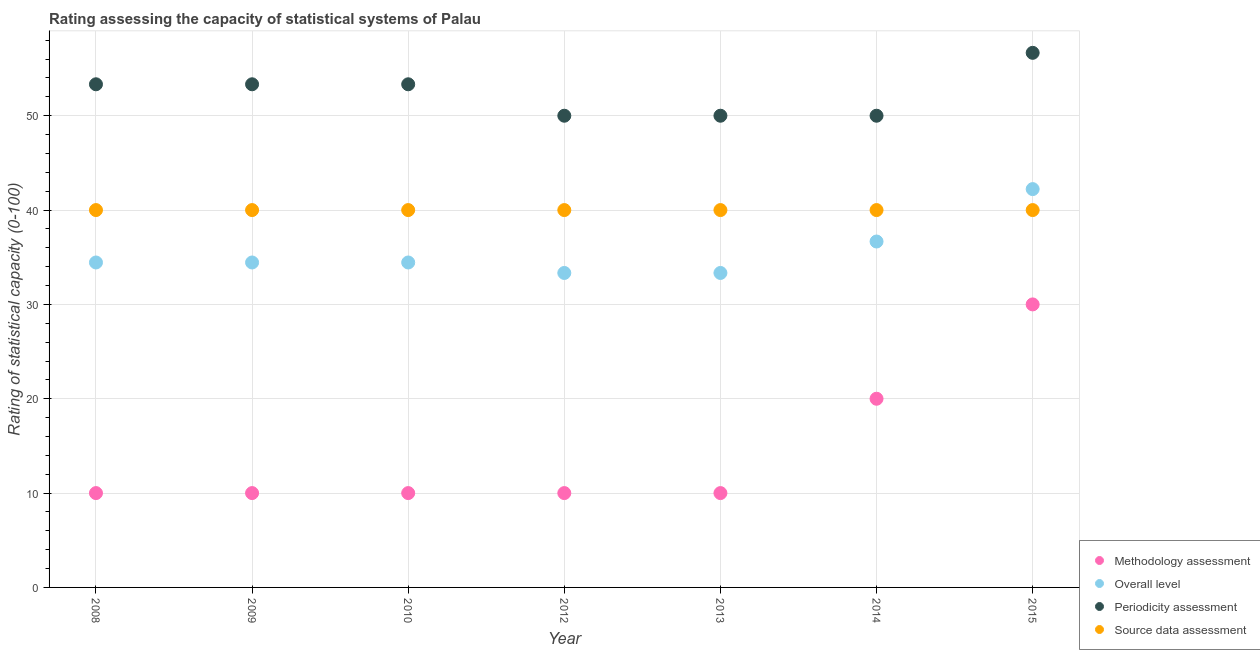What is the methodology assessment rating in 2015?
Offer a terse response. 30. Across all years, what is the maximum periodicity assessment rating?
Provide a succinct answer. 56.67. Across all years, what is the minimum source data assessment rating?
Your response must be concise. 40. In which year was the periodicity assessment rating maximum?
Ensure brevity in your answer.  2015. What is the total periodicity assessment rating in the graph?
Ensure brevity in your answer.  366.67. What is the difference between the overall level rating in 2008 and that in 2010?
Offer a very short reply. 0. What is the difference between the source data assessment rating in 2008 and the overall level rating in 2015?
Offer a terse response. -2.22. What is the average overall level rating per year?
Provide a succinct answer. 35.56. In the year 2012, what is the difference between the overall level rating and periodicity assessment rating?
Offer a terse response. -16.67. In how many years, is the methodology assessment rating greater than 36?
Give a very brief answer. 0. What is the ratio of the methodology assessment rating in 2010 to that in 2013?
Your response must be concise. 1. Is the difference between the source data assessment rating in 2008 and 2015 greater than the difference between the overall level rating in 2008 and 2015?
Your answer should be compact. Yes. What is the difference between the highest and the second highest methodology assessment rating?
Your response must be concise. 10. What is the difference between the highest and the lowest methodology assessment rating?
Your response must be concise. 20. In how many years, is the overall level rating greater than the average overall level rating taken over all years?
Make the answer very short. 2. Is it the case that in every year, the sum of the periodicity assessment rating and source data assessment rating is greater than the sum of overall level rating and methodology assessment rating?
Your answer should be compact. Yes. Is it the case that in every year, the sum of the methodology assessment rating and overall level rating is greater than the periodicity assessment rating?
Offer a terse response. No. Is the methodology assessment rating strictly greater than the source data assessment rating over the years?
Ensure brevity in your answer.  No. What is the difference between two consecutive major ticks on the Y-axis?
Your answer should be very brief. 10. Are the values on the major ticks of Y-axis written in scientific E-notation?
Provide a short and direct response. No. Does the graph contain any zero values?
Give a very brief answer. No. Does the graph contain grids?
Offer a terse response. Yes. What is the title of the graph?
Your answer should be compact. Rating assessing the capacity of statistical systems of Palau. What is the label or title of the X-axis?
Give a very brief answer. Year. What is the label or title of the Y-axis?
Your response must be concise. Rating of statistical capacity (0-100). What is the Rating of statistical capacity (0-100) of Methodology assessment in 2008?
Your response must be concise. 10. What is the Rating of statistical capacity (0-100) of Overall level in 2008?
Keep it short and to the point. 34.44. What is the Rating of statistical capacity (0-100) in Periodicity assessment in 2008?
Offer a very short reply. 53.33. What is the Rating of statistical capacity (0-100) in Overall level in 2009?
Your response must be concise. 34.44. What is the Rating of statistical capacity (0-100) of Periodicity assessment in 2009?
Provide a short and direct response. 53.33. What is the Rating of statistical capacity (0-100) in Source data assessment in 2009?
Offer a terse response. 40. What is the Rating of statistical capacity (0-100) in Overall level in 2010?
Offer a terse response. 34.44. What is the Rating of statistical capacity (0-100) of Periodicity assessment in 2010?
Provide a short and direct response. 53.33. What is the Rating of statistical capacity (0-100) of Methodology assessment in 2012?
Your answer should be very brief. 10. What is the Rating of statistical capacity (0-100) of Overall level in 2012?
Give a very brief answer. 33.33. What is the Rating of statistical capacity (0-100) in Source data assessment in 2012?
Provide a short and direct response. 40. What is the Rating of statistical capacity (0-100) of Overall level in 2013?
Provide a succinct answer. 33.33. What is the Rating of statistical capacity (0-100) of Periodicity assessment in 2013?
Provide a succinct answer. 50. What is the Rating of statistical capacity (0-100) in Source data assessment in 2013?
Offer a terse response. 40. What is the Rating of statistical capacity (0-100) of Methodology assessment in 2014?
Provide a succinct answer. 20. What is the Rating of statistical capacity (0-100) of Overall level in 2014?
Offer a terse response. 36.67. What is the Rating of statistical capacity (0-100) of Periodicity assessment in 2014?
Offer a terse response. 50. What is the Rating of statistical capacity (0-100) of Overall level in 2015?
Ensure brevity in your answer.  42.22. What is the Rating of statistical capacity (0-100) of Periodicity assessment in 2015?
Keep it short and to the point. 56.67. Across all years, what is the maximum Rating of statistical capacity (0-100) of Overall level?
Your answer should be very brief. 42.22. Across all years, what is the maximum Rating of statistical capacity (0-100) in Periodicity assessment?
Your response must be concise. 56.67. Across all years, what is the maximum Rating of statistical capacity (0-100) of Source data assessment?
Provide a short and direct response. 40. Across all years, what is the minimum Rating of statistical capacity (0-100) in Methodology assessment?
Make the answer very short. 10. Across all years, what is the minimum Rating of statistical capacity (0-100) of Overall level?
Give a very brief answer. 33.33. What is the total Rating of statistical capacity (0-100) of Methodology assessment in the graph?
Make the answer very short. 100. What is the total Rating of statistical capacity (0-100) of Overall level in the graph?
Make the answer very short. 248.89. What is the total Rating of statistical capacity (0-100) in Periodicity assessment in the graph?
Provide a succinct answer. 366.67. What is the total Rating of statistical capacity (0-100) of Source data assessment in the graph?
Give a very brief answer. 280. What is the difference between the Rating of statistical capacity (0-100) in Methodology assessment in 2008 and that in 2009?
Offer a very short reply. 0. What is the difference between the Rating of statistical capacity (0-100) of Overall level in 2008 and that in 2009?
Your answer should be compact. 0. What is the difference between the Rating of statistical capacity (0-100) of Periodicity assessment in 2008 and that in 2009?
Make the answer very short. 0. What is the difference between the Rating of statistical capacity (0-100) of Source data assessment in 2008 and that in 2010?
Your answer should be very brief. 0. What is the difference between the Rating of statistical capacity (0-100) of Overall level in 2008 and that in 2013?
Offer a terse response. 1.11. What is the difference between the Rating of statistical capacity (0-100) in Periodicity assessment in 2008 and that in 2013?
Offer a very short reply. 3.33. What is the difference between the Rating of statistical capacity (0-100) in Source data assessment in 2008 and that in 2013?
Offer a very short reply. 0. What is the difference between the Rating of statistical capacity (0-100) in Overall level in 2008 and that in 2014?
Offer a very short reply. -2.22. What is the difference between the Rating of statistical capacity (0-100) in Periodicity assessment in 2008 and that in 2014?
Give a very brief answer. 3.33. What is the difference between the Rating of statistical capacity (0-100) of Source data assessment in 2008 and that in 2014?
Your answer should be very brief. 0. What is the difference between the Rating of statistical capacity (0-100) of Methodology assessment in 2008 and that in 2015?
Provide a succinct answer. -20. What is the difference between the Rating of statistical capacity (0-100) in Overall level in 2008 and that in 2015?
Offer a very short reply. -7.78. What is the difference between the Rating of statistical capacity (0-100) in Source data assessment in 2008 and that in 2015?
Your answer should be compact. 0. What is the difference between the Rating of statistical capacity (0-100) in Overall level in 2009 and that in 2010?
Keep it short and to the point. 0. What is the difference between the Rating of statistical capacity (0-100) in Periodicity assessment in 2009 and that in 2010?
Offer a very short reply. 0. What is the difference between the Rating of statistical capacity (0-100) of Methodology assessment in 2009 and that in 2012?
Offer a very short reply. 0. What is the difference between the Rating of statistical capacity (0-100) of Periodicity assessment in 2009 and that in 2012?
Your response must be concise. 3.33. What is the difference between the Rating of statistical capacity (0-100) of Source data assessment in 2009 and that in 2012?
Offer a terse response. 0. What is the difference between the Rating of statistical capacity (0-100) of Methodology assessment in 2009 and that in 2013?
Your answer should be very brief. 0. What is the difference between the Rating of statistical capacity (0-100) in Periodicity assessment in 2009 and that in 2013?
Your answer should be very brief. 3.33. What is the difference between the Rating of statistical capacity (0-100) in Source data assessment in 2009 and that in 2013?
Offer a very short reply. 0. What is the difference between the Rating of statistical capacity (0-100) of Overall level in 2009 and that in 2014?
Ensure brevity in your answer.  -2.22. What is the difference between the Rating of statistical capacity (0-100) of Periodicity assessment in 2009 and that in 2014?
Ensure brevity in your answer.  3.33. What is the difference between the Rating of statistical capacity (0-100) of Source data assessment in 2009 and that in 2014?
Your answer should be compact. 0. What is the difference between the Rating of statistical capacity (0-100) in Overall level in 2009 and that in 2015?
Keep it short and to the point. -7.78. What is the difference between the Rating of statistical capacity (0-100) of Source data assessment in 2009 and that in 2015?
Provide a short and direct response. 0. What is the difference between the Rating of statistical capacity (0-100) in Methodology assessment in 2010 and that in 2012?
Your response must be concise. 0. What is the difference between the Rating of statistical capacity (0-100) in Periodicity assessment in 2010 and that in 2012?
Your answer should be compact. 3.33. What is the difference between the Rating of statistical capacity (0-100) of Source data assessment in 2010 and that in 2012?
Give a very brief answer. 0. What is the difference between the Rating of statistical capacity (0-100) of Periodicity assessment in 2010 and that in 2013?
Your answer should be very brief. 3.33. What is the difference between the Rating of statistical capacity (0-100) in Source data assessment in 2010 and that in 2013?
Your response must be concise. 0. What is the difference between the Rating of statistical capacity (0-100) in Methodology assessment in 2010 and that in 2014?
Ensure brevity in your answer.  -10. What is the difference between the Rating of statistical capacity (0-100) of Overall level in 2010 and that in 2014?
Your response must be concise. -2.22. What is the difference between the Rating of statistical capacity (0-100) of Methodology assessment in 2010 and that in 2015?
Offer a terse response. -20. What is the difference between the Rating of statistical capacity (0-100) in Overall level in 2010 and that in 2015?
Ensure brevity in your answer.  -7.78. What is the difference between the Rating of statistical capacity (0-100) of Source data assessment in 2010 and that in 2015?
Keep it short and to the point. 0. What is the difference between the Rating of statistical capacity (0-100) in Periodicity assessment in 2012 and that in 2013?
Offer a very short reply. 0. What is the difference between the Rating of statistical capacity (0-100) of Methodology assessment in 2012 and that in 2014?
Provide a short and direct response. -10. What is the difference between the Rating of statistical capacity (0-100) in Periodicity assessment in 2012 and that in 2014?
Offer a very short reply. 0. What is the difference between the Rating of statistical capacity (0-100) of Overall level in 2012 and that in 2015?
Your answer should be compact. -8.89. What is the difference between the Rating of statistical capacity (0-100) in Periodicity assessment in 2012 and that in 2015?
Your response must be concise. -6.67. What is the difference between the Rating of statistical capacity (0-100) of Source data assessment in 2012 and that in 2015?
Give a very brief answer. 0. What is the difference between the Rating of statistical capacity (0-100) of Methodology assessment in 2013 and that in 2014?
Your response must be concise. -10. What is the difference between the Rating of statistical capacity (0-100) in Overall level in 2013 and that in 2014?
Keep it short and to the point. -3.33. What is the difference between the Rating of statistical capacity (0-100) in Source data assessment in 2013 and that in 2014?
Offer a terse response. 0. What is the difference between the Rating of statistical capacity (0-100) of Methodology assessment in 2013 and that in 2015?
Ensure brevity in your answer.  -20. What is the difference between the Rating of statistical capacity (0-100) in Overall level in 2013 and that in 2015?
Provide a succinct answer. -8.89. What is the difference between the Rating of statistical capacity (0-100) of Periodicity assessment in 2013 and that in 2015?
Provide a short and direct response. -6.67. What is the difference between the Rating of statistical capacity (0-100) in Overall level in 2014 and that in 2015?
Provide a succinct answer. -5.56. What is the difference between the Rating of statistical capacity (0-100) of Periodicity assessment in 2014 and that in 2015?
Your answer should be compact. -6.67. What is the difference between the Rating of statistical capacity (0-100) in Methodology assessment in 2008 and the Rating of statistical capacity (0-100) in Overall level in 2009?
Make the answer very short. -24.44. What is the difference between the Rating of statistical capacity (0-100) of Methodology assessment in 2008 and the Rating of statistical capacity (0-100) of Periodicity assessment in 2009?
Make the answer very short. -43.33. What is the difference between the Rating of statistical capacity (0-100) in Overall level in 2008 and the Rating of statistical capacity (0-100) in Periodicity assessment in 2009?
Keep it short and to the point. -18.89. What is the difference between the Rating of statistical capacity (0-100) of Overall level in 2008 and the Rating of statistical capacity (0-100) of Source data assessment in 2009?
Provide a succinct answer. -5.56. What is the difference between the Rating of statistical capacity (0-100) of Periodicity assessment in 2008 and the Rating of statistical capacity (0-100) of Source data assessment in 2009?
Give a very brief answer. 13.33. What is the difference between the Rating of statistical capacity (0-100) of Methodology assessment in 2008 and the Rating of statistical capacity (0-100) of Overall level in 2010?
Make the answer very short. -24.44. What is the difference between the Rating of statistical capacity (0-100) in Methodology assessment in 2008 and the Rating of statistical capacity (0-100) in Periodicity assessment in 2010?
Make the answer very short. -43.33. What is the difference between the Rating of statistical capacity (0-100) of Methodology assessment in 2008 and the Rating of statistical capacity (0-100) of Source data assessment in 2010?
Offer a very short reply. -30. What is the difference between the Rating of statistical capacity (0-100) of Overall level in 2008 and the Rating of statistical capacity (0-100) of Periodicity assessment in 2010?
Make the answer very short. -18.89. What is the difference between the Rating of statistical capacity (0-100) in Overall level in 2008 and the Rating of statistical capacity (0-100) in Source data assessment in 2010?
Keep it short and to the point. -5.56. What is the difference between the Rating of statistical capacity (0-100) of Periodicity assessment in 2008 and the Rating of statistical capacity (0-100) of Source data assessment in 2010?
Keep it short and to the point. 13.33. What is the difference between the Rating of statistical capacity (0-100) of Methodology assessment in 2008 and the Rating of statistical capacity (0-100) of Overall level in 2012?
Provide a succinct answer. -23.33. What is the difference between the Rating of statistical capacity (0-100) in Overall level in 2008 and the Rating of statistical capacity (0-100) in Periodicity assessment in 2012?
Your answer should be compact. -15.56. What is the difference between the Rating of statistical capacity (0-100) in Overall level in 2008 and the Rating of statistical capacity (0-100) in Source data assessment in 2012?
Make the answer very short. -5.56. What is the difference between the Rating of statistical capacity (0-100) in Periodicity assessment in 2008 and the Rating of statistical capacity (0-100) in Source data assessment in 2012?
Give a very brief answer. 13.33. What is the difference between the Rating of statistical capacity (0-100) of Methodology assessment in 2008 and the Rating of statistical capacity (0-100) of Overall level in 2013?
Your response must be concise. -23.33. What is the difference between the Rating of statistical capacity (0-100) in Methodology assessment in 2008 and the Rating of statistical capacity (0-100) in Periodicity assessment in 2013?
Make the answer very short. -40. What is the difference between the Rating of statistical capacity (0-100) of Overall level in 2008 and the Rating of statistical capacity (0-100) of Periodicity assessment in 2013?
Provide a succinct answer. -15.56. What is the difference between the Rating of statistical capacity (0-100) of Overall level in 2008 and the Rating of statistical capacity (0-100) of Source data assessment in 2013?
Make the answer very short. -5.56. What is the difference between the Rating of statistical capacity (0-100) in Periodicity assessment in 2008 and the Rating of statistical capacity (0-100) in Source data assessment in 2013?
Keep it short and to the point. 13.33. What is the difference between the Rating of statistical capacity (0-100) of Methodology assessment in 2008 and the Rating of statistical capacity (0-100) of Overall level in 2014?
Ensure brevity in your answer.  -26.67. What is the difference between the Rating of statistical capacity (0-100) in Methodology assessment in 2008 and the Rating of statistical capacity (0-100) in Periodicity assessment in 2014?
Keep it short and to the point. -40. What is the difference between the Rating of statistical capacity (0-100) of Methodology assessment in 2008 and the Rating of statistical capacity (0-100) of Source data assessment in 2014?
Your answer should be compact. -30. What is the difference between the Rating of statistical capacity (0-100) in Overall level in 2008 and the Rating of statistical capacity (0-100) in Periodicity assessment in 2014?
Provide a succinct answer. -15.56. What is the difference between the Rating of statistical capacity (0-100) in Overall level in 2008 and the Rating of statistical capacity (0-100) in Source data assessment in 2014?
Make the answer very short. -5.56. What is the difference between the Rating of statistical capacity (0-100) of Periodicity assessment in 2008 and the Rating of statistical capacity (0-100) of Source data assessment in 2014?
Ensure brevity in your answer.  13.33. What is the difference between the Rating of statistical capacity (0-100) in Methodology assessment in 2008 and the Rating of statistical capacity (0-100) in Overall level in 2015?
Your answer should be compact. -32.22. What is the difference between the Rating of statistical capacity (0-100) in Methodology assessment in 2008 and the Rating of statistical capacity (0-100) in Periodicity assessment in 2015?
Offer a terse response. -46.67. What is the difference between the Rating of statistical capacity (0-100) of Overall level in 2008 and the Rating of statistical capacity (0-100) of Periodicity assessment in 2015?
Keep it short and to the point. -22.22. What is the difference between the Rating of statistical capacity (0-100) in Overall level in 2008 and the Rating of statistical capacity (0-100) in Source data assessment in 2015?
Provide a short and direct response. -5.56. What is the difference between the Rating of statistical capacity (0-100) in Periodicity assessment in 2008 and the Rating of statistical capacity (0-100) in Source data assessment in 2015?
Make the answer very short. 13.33. What is the difference between the Rating of statistical capacity (0-100) in Methodology assessment in 2009 and the Rating of statistical capacity (0-100) in Overall level in 2010?
Make the answer very short. -24.44. What is the difference between the Rating of statistical capacity (0-100) in Methodology assessment in 2009 and the Rating of statistical capacity (0-100) in Periodicity assessment in 2010?
Make the answer very short. -43.33. What is the difference between the Rating of statistical capacity (0-100) of Overall level in 2009 and the Rating of statistical capacity (0-100) of Periodicity assessment in 2010?
Provide a short and direct response. -18.89. What is the difference between the Rating of statistical capacity (0-100) of Overall level in 2009 and the Rating of statistical capacity (0-100) of Source data assessment in 2010?
Your response must be concise. -5.56. What is the difference between the Rating of statistical capacity (0-100) in Periodicity assessment in 2009 and the Rating of statistical capacity (0-100) in Source data assessment in 2010?
Offer a very short reply. 13.33. What is the difference between the Rating of statistical capacity (0-100) of Methodology assessment in 2009 and the Rating of statistical capacity (0-100) of Overall level in 2012?
Your answer should be compact. -23.33. What is the difference between the Rating of statistical capacity (0-100) in Overall level in 2009 and the Rating of statistical capacity (0-100) in Periodicity assessment in 2012?
Make the answer very short. -15.56. What is the difference between the Rating of statistical capacity (0-100) of Overall level in 2009 and the Rating of statistical capacity (0-100) of Source data assessment in 2012?
Your response must be concise. -5.56. What is the difference between the Rating of statistical capacity (0-100) in Periodicity assessment in 2009 and the Rating of statistical capacity (0-100) in Source data assessment in 2012?
Your answer should be very brief. 13.33. What is the difference between the Rating of statistical capacity (0-100) in Methodology assessment in 2009 and the Rating of statistical capacity (0-100) in Overall level in 2013?
Provide a succinct answer. -23.33. What is the difference between the Rating of statistical capacity (0-100) of Overall level in 2009 and the Rating of statistical capacity (0-100) of Periodicity assessment in 2013?
Provide a succinct answer. -15.56. What is the difference between the Rating of statistical capacity (0-100) of Overall level in 2009 and the Rating of statistical capacity (0-100) of Source data assessment in 2013?
Make the answer very short. -5.56. What is the difference between the Rating of statistical capacity (0-100) in Periodicity assessment in 2009 and the Rating of statistical capacity (0-100) in Source data assessment in 2013?
Your answer should be compact. 13.33. What is the difference between the Rating of statistical capacity (0-100) of Methodology assessment in 2009 and the Rating of statistical capacity (0-100) of Overall level in 2014?
Give a very brief answer. -26.67. What is the difference between the Rating of statistical capacity (0-100) of Methodology assessment in 2009 and the Rating of statistical capacity (0-100) of Periodicity assessment in 2014?
Offer a terse response. -40. What is the difference between the Rating of statistical capacity (0-100) of Overall level in 2009 and the Rating of statistical capacity (0-100) of Periodicity assessment in 2014?
Give a very brief answer. -15.56. What is the difference between the Rating of statistical capacity (0-100) in Overall level in 2009 and the Rating of statistical capacity (0-100) in Source data assessment in 2014?
Make the answer very short. -5.56. What is the difference between the Rating of statistical capacity (0-100) of Periodicity assessment in 2009 and the Rating of statistical capacity (0-100) of Source data assessment in 2014?
Ensure brevity in your answer.  13.33. What is the difference between the Rating of statistical capacity (0-100) of Methodology assessment in 2009 and the Rating of statistical capacity (0-100) of Overall level in 2015?
Provide a succinct answer. -32.22. What is the difference between the Rating of statistical capacity (0-100) in Methodology assessment in 2009 and the Rating of statistical capacity (0-100) in Periodicity assessment in 2015?
Ensure brevity in your answer.  -46.67. What is the difference between the Rating of statistical capacity (0-100) of Overall level in 2009 and the Rating of statistical capacity (0-100) of Periodicity assessment in 2015?
Offer a very short reply. -22.22. What is the difference between the Rating of statistical capacity (0-100) of Overall level in 2009 and the Rating of statistical capacity (0-100) of Source data assessment in 2015?
Give a very brief answer. -5.56. What is the difference between the Rating of statistical capacity (0-100) in Periodicity assessment in 2009 and the Rating of statistical capacity (0-100) in Source data assessment in 2015?
Your response must be concise. 13.33. What is the difference between the Rating of statistical capacity (0-100) of Methodology assessment in 2010 and the Rating of statistical capacity (0-100) of Overall level in 2012?
Keep it short and to the point. -23.33. What is the difference between the Rating of statistical capacity (0-100) of Overall level in 2010 and the Rating of statistical capacity (0-100) of Periodicity assessment in 2012?
Keep it short and to the point. -15.56. What is the difference between the Rating of statistical capacity (0-100) in Overall level in 2010 and the Rating of statistical capacity (0-100) in Source data assessment in 2012?
Provide a short and direct response. -5.56. What is the difference between the Rating of statistical capacity (0-100) in Periodicity assessment in 2010 and the Rating of statistical capacity (0-100) in Source data assessment in 2012?
Your response must be concise. 13.33. What is the difference between the Rating of statistical capacity (0-100) of Methodology assessment in 2010 and the Rating of statistical capacity (0-100) of Overall level in 2013?
Ensure brevity in your answer.  -23.33. What is the difference between the Rating of statistical capacity (0-100) of Overall level in 2010 and the Rating of statistical capacity (0-100) of Periodicity assessment in 2013?
Give a very brief answer. -15.56. What is the difference between the Rating of statistical capacity (0-100) of Overall level in 2010 and the Rating of statistical capacity (0-100) of Source data assessment in 2013?
Offer a terse response. -5.56. What is the difference between the Rating of statistical capacity (0-100) of Periodicity assessment in 2010 and the Rating of statistical capacity (0-100) of Source data assessment in 2013?
Your answer should be compact. 13.33. What is the difference between the Rating of statistical capacity (0-100) of Methodology assessment in 2010 and the Rating of statistical capacity (0-100) of Overall level in 2014?
Ensure brevity in your answer.  -26.67. What is the difference between the Rating of statistical capacity (0-100) in Methodology assessment in 2010 and the Rating of statistical capacity (0-100) in Periodicity assessment in 2014?
Offer a very short reply. -40. What is the difference between the Rating of statistical capacity (0-100) in Methodology assessment in 2010 and the Rating of statistical capacity (0-100) in Source data assessment in 2014?
Your answer should be compact. -30. What is the difference between the Rating of statistical capacity (0-100) of Overall level in 2010 and the Rating of statistical capacity (0-100) of Periodicity assessment in 2014?
Ensure brevity in your answer.  -15.56. What is the difference between the Rating of statistical capacity (0-100) of Overall level in 2010 and the Rating of statistical capacity (0-100) of Source data assessment in 2014?
Keep it short and to the point. -5.56. What is the difference between the Rating of statistical capacity (0-100) in Periodicity assessment in 2010 and the Rating of statistical capacity (0-100) in Source data assessment in 2014?
Make the answer very short. 13.33. What is the difference between the Rating of statistical capacity (0-100) in Methodology assessment in 2010 and the Rating of statistical capacity (0-100) in Overall level in 2015?
Your response must be concise. -32.22. What is the difference between the Rating of statistical capacity (0-100) in Methodology assessment in 2010 and the Rating of statistical capacity (0-100) in Periodicity assessment in 2015?
Give a very brief answer. -46.67. What is the difference between the Rating of statistical capacity (0-100) in Methodology assessment in 2010 and the Rating of statistical capacity (0-100) in Source data assessment in 2015?
Provide a succinct answer. -30. What is the difference between the Rating of statistical capacity (0-100) in Overall level in 2010 and the Rating of statistical capacity (0-100) in Periodicity assessment in 2015?
Offer a very short reply. -22.22. What is the difference between the Rating of statistical capacity (0-100) in Overall level in 2010 and the Rating of statistical capacity (0-100) in Source data assessment in 2015?
Provide a short and direct response. -5.56. What is the difference between the Rating of statistical capacity (0-100) in Periodicity assessment in 2010 and the Rating of statistical capacity (0-100) in Source data assessment in 2015?
Give a very brief answer. 13.33. What is the difference between the Rating of statistical capacity (0-100) in Methodology assessment in 2012 and the Rating of statistical capacity (0-100) in Overall level in 2013?
Your response must be concise. -23.33. What is the difference between the Rating of statistical capacity (0-100) of Overall level in 2012 and the Rating of statistical capacity (0-100) of Periodicity assessment in 2013?
Ensure brevity in your answer.  -16.67. What is the difference between the Rating of statistical capacity (0-100) of Overall level in 2012 and the Rating of statistical capacity (0-100) of Source data assessment in 2013?
Offer a very short reply. -6.67. What is the difference between the Rating of statistical capacity (0-100) of Methodology assessment in 2012 and the Rating of statistical capacity (0-100) of Overall level in 2014?
Your response must be concise. -26.67. What is the difference between the Rating of statistical capacity (0-100) of Methodology assessment in 2012 and the Rating of statistical capacity (0-100) of Periodicity assessment in 2014?
Your answer should be compact. -40. What is the difference between the Rating of statistical capacity (0-100) in Overall level in 2012 and the Rating of statistical capacity (0-100) in Periodicity assessment in 2014?
Provide a short and direct response. -16.67. What is the difference between the Rating of statistical capacity (0-100) of Overall level in 2012 and the Rating of statistical capacity (0-100) of Source data assessment in 2014?
Make the answer very short. -6.67. What is the difference between the Rating of statistical capacity (0-100) of Methodology assessment in 2012 and the Rating of statistical capacity (0-100) of Overall level in 2015?
Offer a very short reply. -32.22. What is the difference between the Rating of statistical capacity (0-100) in Methodology assessment in 2012 and the Rating of statistical capacity (0-100) in Periodicity assessment in 2015?
Your response must be concise. -46.67. What is the difference between the Rating of statistical capacity (0-100) of Methodology assessment in 2012 and the Rating of statistical capacity (0-100) of Source data assessment in 2015?
Offer a terse response. -30. What is the difference between the Rating of statistical capacity (0-100) of Overall level in 2012 and the Rating of statistical capacity (0-100) of Periodicity assessment in 2015?
Your answer should be compact. -23.33. What is the difference between the Rating of statistical capacity (0-100) of Overall level in 2012 and the Rating of statistical capacity (0-100) of Source data assessment in 2015?
Make the answer very short. -6.67. What is the difference between the Rating of statistical capacity (0-100) in Periodicity assessment in 2012 and the Rating of statistical capacity (0-100) in Source data assessment in 2015?
Your answer should be very brief. 10. What is the difference between the Rating of statistical capacity (0-100) in Methodology assessment in 2013 and the Rating of statistical capacity (0-100) in Overall level in 2014?
Provide a short and direct response. -26.67. What is the difference between the Rating of statistical capacity (0-100) of Overall level in 2013 and the Rating of statistical capacity (0-100) of Periodicity assessment in 2014?
Your response must be concise. -16.67. What is the difference between the Rating of statistical capacity (0-100) of Overall level in 2013 and the Rating of statistical capacity (0-100) of Source data assessment in 2014?
Offer a terse response. -6.67. What is the difference between the Rating of statistical capacity (0-100) of Methodology assessment in 2013 and the Rating of statistical capacity (0-100) of Overall level in 2015?
Your answer should be very brief. -32.22. What is the difference between the Rating of statistical capacity (0-100) of Methodology assessment in 2013 and the Rating of statistical capacity (0-100) of Periodicity assessment in 2015?
Offer a very short reply. -46.67. What is the difference between the Rating of statistical capacity (0-100) of Methodology assessment in 2013 and the Rating of statistical capacity (0-100) of Source data assessment in 2015?
Your response must be concise. -30. What is the difference between the Rating of statistical capacity (0-100) of Overall level in 2013 and the Rating of statistical capacity (0-100) of Periodicity assessment in 2015?
Give a very brief answer. -23.33. What is the difference between the Rating of statistical capacity (0-100) of Overall level in 2013 and the Rating of statistical capacity (0-100) of Source data assessment in 2015?
Offer a terse response. -6.67. What is the difference between the Rating of statistical capacity (0-100) of Periodicity assessment in 2013 and the Rating of statistical capacity (0-100) of Source data assessment in 2015?
Give a very brief answer. 10. What is the difference between the Rating of statistical capacity (0-100) in Methodology assessment in 2014 and the Rating of statistical capacity (0-100) in Overall level in 2015?
Keep it short and to the point. -22.22. What is the difference between the Rating of statistical capacity (0-100) of Methodology assessment in 2014 and the Rating of statistical capacity (0-100) of Periodicity assessment in 2015?
Make the answer very short. -36.67. What is the difference between the Rating of statistical capacity (0-100) of Methodology assessment in 2014 and the Rating of statistical capacity (0-100) of Source data assessment in 2015?
Give a very brief answer. -20. What is the difference between the Rating of statistical capacity (0-100) of Overall level in 2014 and the Rating of statistical capacity (0-100) of Periodicity assessment in 2015?
Give a very brief answer. -20. What is the average Rating of statistical capacity (0-100) in Methodology assessment per year?
Your answer should be compact. 14.29. What is the average Rating of statistical capacity (0-100) of Overall level per year?
Make the answer very short. 35.56. What is the average Rating of statistical capacity (0-100) of Periodicity assessment per year?
Your response must be concise. 52.38. In the year 2008, what is the difference between the Rating of statistical capacity (0-100) in Methodology assessment and Rating of statistical capacity (0-100) in Overall level?
Give a very brief answer. -24.44. In the year 2008, what is the difference between the Rating of statistical capacity (0-100) in Methodology assessment and Rating of statistical capacity (0-100) in Periodicity assessment?
Provide a succinct answer. -43.33. In the year 2008, what is the difference between the Rating of statistical capacity (0-100) in Overall level and Rating of statistical capacity (0-100) in Periodicity assessment?
Offer a very short reply. -18.89. In the year 2008, what is the difference between the Rating of statistical capacity (0-100) in Overall level and Rating of statistical capacity (0-100) in Source data assessment?
Give a very brief answer. -5.56. In the year 2008, what is the difference between the Rating of statistical capacity (0-100) in Periodicity assessment and Rating of statistical capacity (0-100) in Source data assessment?
Keep it short and to the point. 13.33. In the year 2009, what is the difference between the Rating of statistical capacity (0-100) of Methodology assessment and Rating of statistical capacity (0-100) of Overall level?
Make the answer very short. -24.44. In the year 2009, what is the difference between the Rating of statistical capacity (0-100) in Methodology assessment and Rating of statistical capacity (0-100) in Periodicity assessment?
Your answer should be compact. -43.33. In the year 2009, what is the difference between the Rating of statistical capacity (0-100) in Overall level and Rating of statistical capacity (0-100) in Periodicity assessment?
Your response must be concise. -18.89. In the year 2009, what is the difference between the Rating of statistical capacity (0-100) in Overall level and Rating of statistical capacity (0-100) in Source data assessment?
Offer a very short reply. -5.56. In the year 2009, what is the difference between the Rating of statistical capacity (0-100) of Periodicity assessment and Rating of statistical capacity (0-100) of Source data assessment?
Your answer should be compact. 13.33. In the year 2010, what is the difference between the Rating of statistical capacity (0-100) in Methodology assessment and Rating of statistical capacity (0-100) in Overall level?
Your answer should be very brief. -24.44. In the year 2010, what is the difference between the Rating of statistical capacity (0-100) in Methodology assessment and Rating of statistical capacity (0-100) in Periodicity assessment?
Make the answer very short. -43.33. In the year 2010, what is the difference between the Rating of statistical capacity (0-100) in Overall level and Rating of statistical capacity (0-100) in Periodicity assessment?
Offer a very short reply. -18.89. In the year 2010, what is the difference between the Rating of statistical capacity (0-100) in Overall level and Rating of statistical capacity (0-100) in Source data assessment?
Your response must be concise. -5.56. In the year 2010, what is the difference between the Rating of statistical capacity (0-100) in Periodicity assessment and Rating of statistical capacity (0-100) in Source data assessment?
Offer a very short reply. 13.33. In the year 2012, what is the difference between the Rating of statistical capacity (0-100) in Methodology assessment and Rating of statistical capacity (0-100) in Overall level?
Your answer should be compact. -23.33. In the year 2012, what is the difference between the Rating of statistical capacity (0-100) of Methodology assessment and Rating of statistical capacity (0-100) of Periodicity assessment?
Provide a short and direct response. -40. In the year 2012, what is the difference between the Rating of statistical capacity (0-100) in Overall level and Rating of statistical capacity (0-100) in Periodicity assessment?
Ensure brevity in your answer.  -16.67. In the year 2012, what is the difference between the Rating of statistical capacity (0-100) of Overall level and Rating of statistical capacity (0-100) of Source data assessment?
Keep it short and to the point. -6.67. In the year 2012, what is the difference between the Rating of statistical capacity (0-100) in Periodicity assessment and Rating of statistical capacity (0-100) in Source data assessment?
Your answer should be compact. 10. In the year 2013, what is the difference between the Rating of statistical capacity (0-100) of Methodology assessment and Rating of statistical capacity (0-100) of Overall level?
Offer a terse response. -23.33. In the year 2013, what is the difference between the Rating of statistical capacity (0-100) of Methodology assessment and Rating of statistical capacity (0-100) of Periodicity assessment?
Give a very brief answer. -40. In the year 2013, what is the difference between the Rating of statistical capacity (0-100) in Methodology assessment and Rating of statistical capacity (0-100) in Source data assessment?
Give a very brief answer. -30. In the year 2013, what is the difference between the Rating of statistical capacity (0-100) in Overall level and Rating of statistical capacity (0-100) in Periodicity assessment?
Your answer should be very brief. -16.67. In the year 2013, what is the difference between the Rating of statistical capacity (0-100) in Overall level and Rating of statistical capacity (0-100) in Source data assessment?
Provide a succinct answer. -6.67. In the year 2014, what is the difference between the Rating of statistical capacity (0-100) in Methodology assessment and Rating of statistical capacity (0-100) in Overall level?
Your answer should be compact. -16.67. In the year 2014, what is the difference between the Rating of statistical capacity (0-100) in Methodology assessment and Rating of statistical capacity (0-100) in Source data assessment?
Ensure brevity in your answer.  -20. In the year 2014, what is the difference between the Rating of statistical capacity (0-100) in Overall level and Rating of statistical capacity (0-100) in Periodicity assessment?
Ensure brevity in your answer.  -13.33. In the year 2015, what is the difference between the Rating of statistical capacity (0-100) in Methodology assessment and Rating of statistical capacity (0-100) in Overall level?
Your answer should be very brief. -12.22. In the year 2015, what is the difference between the Rating of statistical capacity (0-100) of Methodology assessment and Rating of statistical capacity (0-100) of Periodicity assessment?
Make the answer very short. -26.67. In the year 2015, what is the difference between the Rating of statistical capacity (0-100) in Overall level and Rating of statistical capacity (0-100) in Periodicity assessment?
Provide a short and direct response. -14.44. In the year 2015, what is the difference between the Rating of statistical capacity (0-100) of Overall level and Rating of statistical capacity (0-100) of Source data assessment?
Offer a terse response. 2.22. In the year 2015, what is the difference between the Rating of statistical capacity (0-100) of Periodicity assessment and Rating of statistical capacity (0-100) of Source data assessment?
Your answer should be very brief. 16.67. What is the ratio of the Rating of statistical capacity (0-100) in Methodology assessment in 2008 to that in 2009?
Offer a terse response. 1. What is the ratio of the Rating of statistical capacity (0-100) in Overall level in 2008 to that in 2009?
Keep it short and to the point. 1. What is the ratio of the Rating of statistical capacity (0-100) in Source data assessment in 2008 to that in 2009?
Your answer should be very brief. 1. What is the ratio of the Rating of statistical capacity (0-100) in Overall level in 2008 to that in 2010?
Provide a short and direct response. 1. What is the ratio of the Rating of statistical capacity (0-100) in Methodology assessment in 2008 to that in 2012?
Give a very brief answer. 1. What is the ratio of the Rating of statistical capacity (0-100) of Periodicity assessment in 2008 to that in 2012?
Offer a terse response. 1.07. What is the ratio of the Rating of statistical capacity (0-100) in Source data assessment in 2008 to that in 2012?
Offer a very short reply. 1. What is the ratio of the Rating of statistical capacity (0-100) of Periodicity assessment in 2008 to that in 2013?
Keep it short and to the point. 1.07. What is the ratio of the Rating of statistical capacity (0-100) in Overall level in 2008 to that in 2014?
Your response must be concise. 0.94. What is the ratio of the Rating of statistical capacity (0-100) in Periodicity assessment in 2008 to that in 2014?
Give a very brief answer. 1.07. What is the ratio of the Rating of statistical capacity (0-100) of Source data assessment in 2008 to that in 2014?
Ensure brevity in your answer.  1. What is the ratio of the Rating of statistical capacity (0-100) of Overall level in 2008 to that in 2015?
Provide a short and direct response. 0.82. What is the ratio of the Rating of statistical capacity (0-100) in Periodicity assessment in 2008 to that in 2015?
Provide a succinct answer. 0.94. What is the ratio of the Rating of statistical capacity (0-100) in Source data assessment in 2008 to that in 2015?
Your answer should be compact. 1. What is the ratio of the Rating of statistical capacity (0-100) of Overall level in 2009 to that in 2010?
Give a very brief answer. 1. What is the ratio of the Rating of statistical capacity (0-100) of Methodology assessment in 2009 to that in 2012?
Ensure brevity in your answer.  1. What is the ratio of the Rating of statistical capacity (0-100) of Periodicity assessment in 2009 to that in 2012?
Offer a terse response. 1.07. What is the ratio of the Rating of statistical capacity (0-100) of Source data assessment in 2009 to that in 2012?
Your answer should be compact. 1. What is the ratio of the Rating of statistical capacity (0-100) of Overall level in 2009 to that in 2013?
Offer a very short reply. 1.03. What is the ratio of the Rating of statistical capacity (0-100) of Periodicity assessment in 2009 to that in 2013?
Provide a short and direct response. 1.07. What is the ratio of the Rating of statistical capacity (0-100) in Source data assessment in 2009 to that in 2013?
Offer a very short reply. 1. What is the ratio of the Rating of statistical capacity (0-100) in Methodology assessment in 2009 to that in 2014?
Give a very brief answer. 0.5. What is the ratio of the Rating of statistical capacity (0-100) of Overall level in 2009 to that in 2014?
Offer a terse response. 0.94. What is the ratio of the Rating of statistical capacity (0-100) of Periodicity assessment in 2009 to that in 2014?
Provide a short and direct response. 1.07. What is the ratio of the Rating of statistical capacity (0-100) in Methodology assessment in 2009 to that in 2015?
Make the answer very short. 0.33. What is the ratio of the Rating of statistical capacity (0-100) in Overall level in 2009 to that in 2015?
Provide a succinct answer. 0.82. What is the ratio of the Rating of statistical capacity (0-100) in Overall level in 2010 to that in 2012?
Your response must be concise. 1.03. What is the ratio of the Rating of statistical capacity (0-100) in Periodicity assessment in 2010 to that in 2012?
Your answer should be very brief. 1.07. What is the ratio of the Rating of statistical capacity (0-100) of Periodicity assessment in 2010 to that in 2013?
Your answer should be very brief. 1.07. What is the ratio of the Rating of statistical capacity (0-100) of Source data assessment in 2010 to that in 2013?
Provide a succinct answer. 1. What is the ratio of the Rating of statistical capacity (0-100) in Methodology assessment in 2010 to that in 2014?
Your answer should be very brief. 0.5. What is the ratio of the Rating of statistical capacity (0-100) of Overall level in 2010 to that in 2014?
Keep it short and to the point. 0.94. What is the ratio of the Rating of statistical capacity (0-100) in Periodicity assessment in 2010 to that in 2014?
Offer a very short reply. 1.07. What is the ratio of the Rating of statistical capacity (0-100) in Overall level in 2010 to that in 2015?
Give a very brief answer. 0.82. What is the ratio of the Rating of statistical capacity (0-100) in Methodology assessment in 2012 to that in 2013?
Your response must be concise. 1. What is the ratio of the Rating of statistical capacity (0-100) of Methodology assessment in 2012 to that in 2014?
Make the answer very short. 0.5. What is the ratio of the Rating of statistical capacity (0-100) of Periodicity assessment in 2012 to that in 2014?
Your answer should be compact. 1. What is the ratio of the Rating of statistical capacity (0-100) in Source data assessment in 2012 to that in 2014?
Make the answer very short. 1. What is the ratio of the Rating of statistical capacity (0-100) in Overall level in 2012 to that in 2015?
Offer a terse response. 0.79. What is the ratio of the Rating of statistical capacity (0-100) of Periodicity assessment in 2012 to that in 2015?
Ensure brevity in your answer.  0.88. What is the ratio of the Rating of statistical capacity (0-100) in Overall level in 2013 to that in 2014?
Give a very brief answer. 0.91. What is the ratio of the Rating of statistical capacity (0-100) in Source data assessment in 2013 to that in 2014?
Your answer should be compact. 1. What is the ratio of the Rating of statistical capacity (0-100) of Overall level in 2013 to that in 2015?
Provide a short and direct response. 0.79. What is the ratio of the Rating of statistical capacity (0-100) in Periodicity assessment in 2013 to that in 2015?
Offer a terse response. 0.88. What is the ratio of the Rating of statistical capacity (0-100) in Methodology assessment in 2014 to that in 2015?
Offer a very short reply. 0.67. What is the ratio of the Rating of statistical capacity (0-100) of Overall level in 2014 to that in 2015?
Offer a very short reply. 0.87. What is the ratio of the Rating of statistical capacity (0-100) of Periodicity assessment in 2014 to that in 2015?
Your answer should be very brief. 0.88. What is the ratio of the Rating of statistical capacity (0-100) of Source data assessment in 2014 to that in 2015?
Offer a terse response. 1. What is the difference between the highest and the second highest Rating of statistical capacity (0-100) of Overall level?
Your answer should be very brief. 5.56. What is the difference between the highest and the second highest Rating of statistical capacity (0-100) in Source data assessment?
Provide a succinct answer. 0. What is the difference between the highest and the lowest Rating of statistical capacity (0-100) in Overall level?
Ensure brevity in your answer.  8.89. What is the difference between the highest and the lowest Rating of statistical capacity (0-100) in Periodicity assessment?
Your answer should be compact. 6.67. What is the difference between the highest and the lowest Rating of statistical capacity (0-100) in Source data assessment?
Your answer should be compact. 0. 